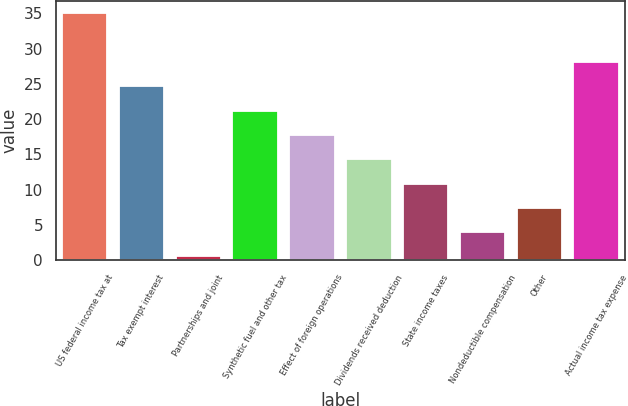Convert chart. <chart><loc_0><loc_0><loc_500><loc_500><bar_chart><fcel>US federal income tax at<fcel>Tax exempt interest<fcel>Partnerships and joint<fcel>Synthetic fuel and other tax<fcel>Effect of foreign operations<fcel>Dividends received deduction<fcel>State income taxes<fcel>Nondeductible compensation<fcel>Other<fcel>Actual income tax expense<nl><fcel>35<fcel>24.65<fcel>0.5<fcel>21.2<fcel>17.75<fcel>14.3<fcel>10.85<fcel>3.95<fcel>7.4<fcel>28.1<nl></chart> 